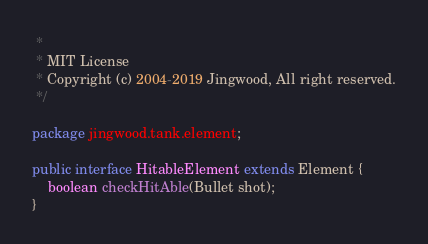Convert code to text. <code><loc_0><loc_0><loc_500><loc_500><_Java_> *
 * MIT License
 * Copyright (c) 2004-2019 Jingwood, All right reserved.
 */

package jingwood.tank.element;

public interface HitableElement extends Element {
	boolean checkHitAble(Bullet shot);
}
</code> 